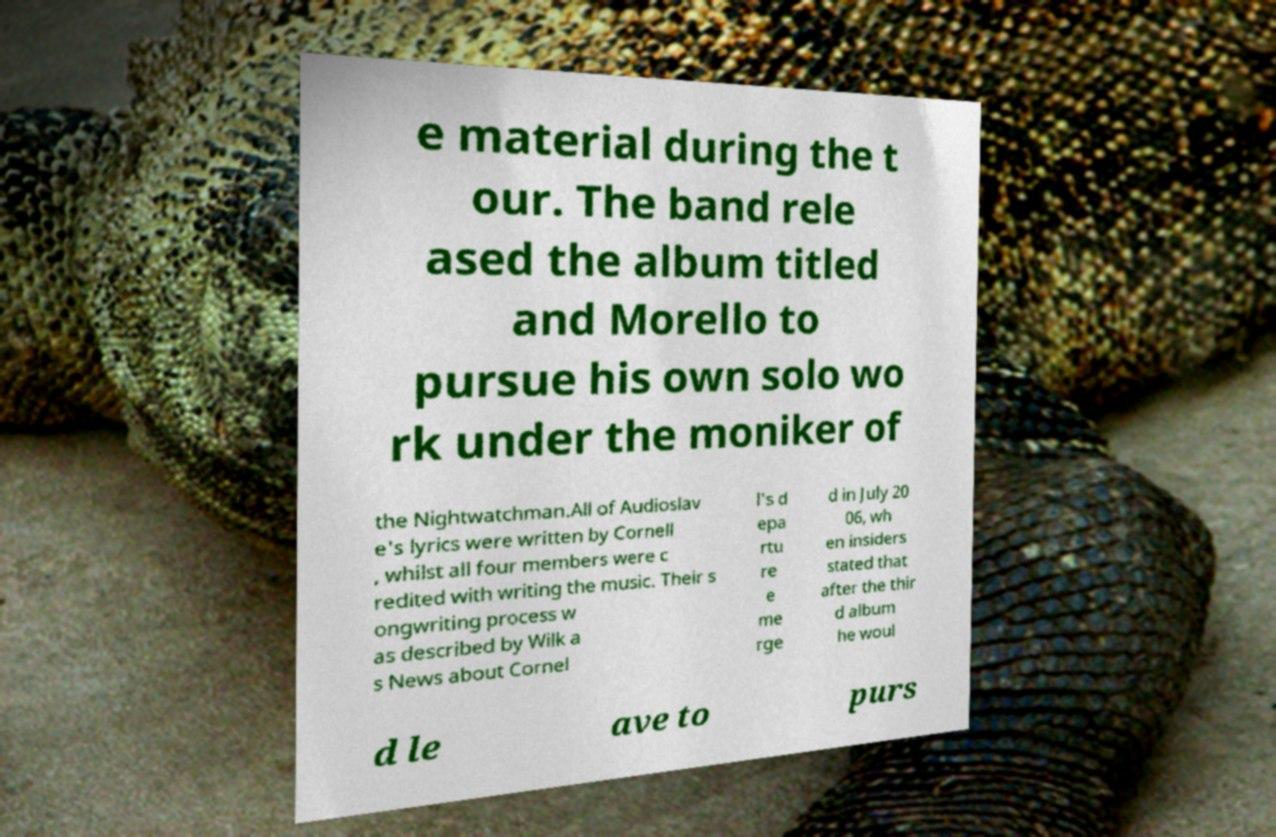Can you read and provide the text displayed in the image?This photo seems to have some interesting text. Can you extract and type it out for me? e material during the t our. The band rele ased the album titled and Morello to pursue his own solo wo rk under the moniker of the Nightwatchman.All of Audioslav e's lyrics were written by Cornell , whilst all four members were c redited with writing the music. Their s ongwriting process w as described by Wilk a s News about Cornel l's d epa rtu re e me rge d in July 20 06, wh en insiders stated that after the thir d album he woul d le ave to purs 